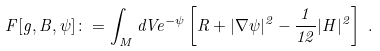Convert formula to latex. <formula><loc_0><loc_0><loc_500><loc_500>F [ g , B , \psi ] \colon = \int _ { M } d V e ^ { - \psi } \left [ R + | \nabla \psi | ^ { 2 } - \frac { 1 } { 1 2 } | H | ^ { 2 } \right ] \ .</formula> 